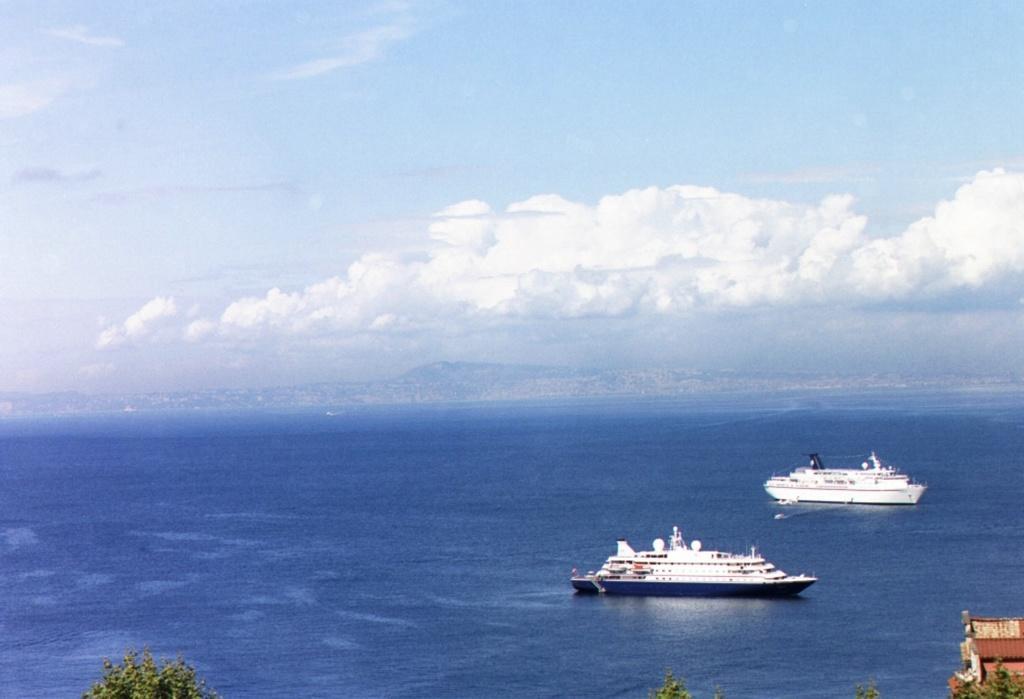Please provide a concise description of this image. In this picture we can see some ships in a ocean and we can see trees, clouded sky. 